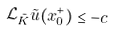Convert formula to latex. <formula><loc_0><loc_0><loc_500><loc_500>\mathcal { L } _ { \tilde { K } } \tilde { u } ( x _ { 0 } ^ { + } ) \leq - c</formula> 